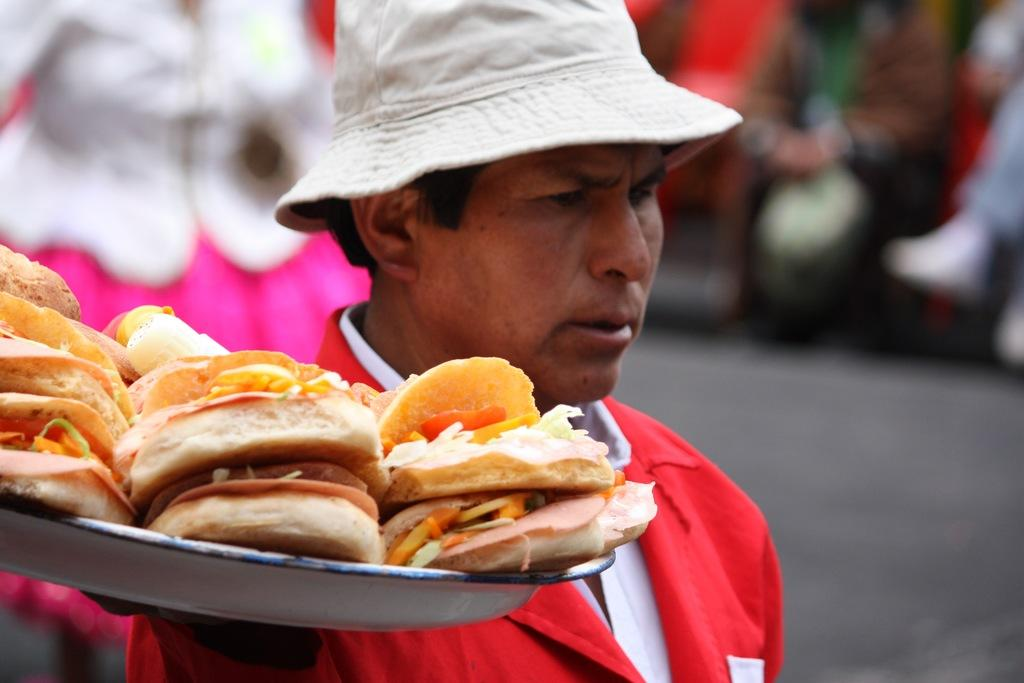What is present in the image? There is a person in the image. What is the person holding? The person is holding a food item. How is the food item contained? The food item is in a container. What type of square banana can be seen in the image? There is no banana, square or otherwise, present in the image. 